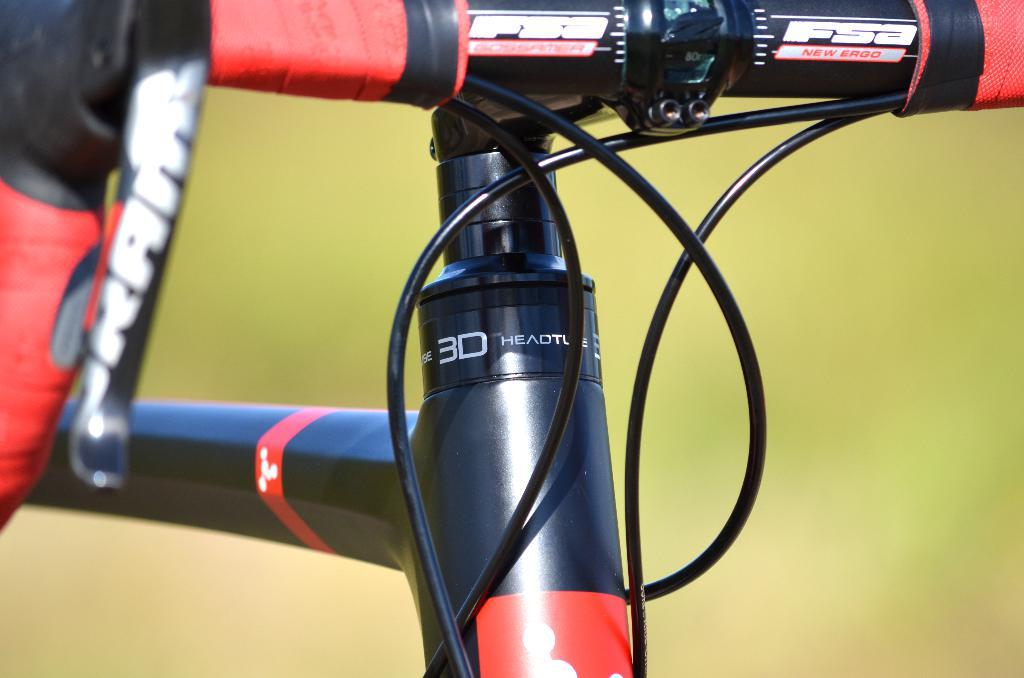What is the main subject of the image? The main subject of the image is a half part of a bicycle. Are there any specific features visible on the bicycle? Yes, there are cables visible in the image. Can you describe the background of the image? The background of the image is blurry. What type of goose can be seen writing a message on a dime in the image? There is no goose or dime present in the image, and therefore no such activity can be observed. 